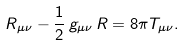Convert formula to latex. <formula><loc_0><loc_0><loc_500><loc_500>R _ { \mu \nu } - \frac { 1 } { 2 } \, g _ { \mu \nu } \, R = 8 \pi T _ { \mu \nu } .</formula> 